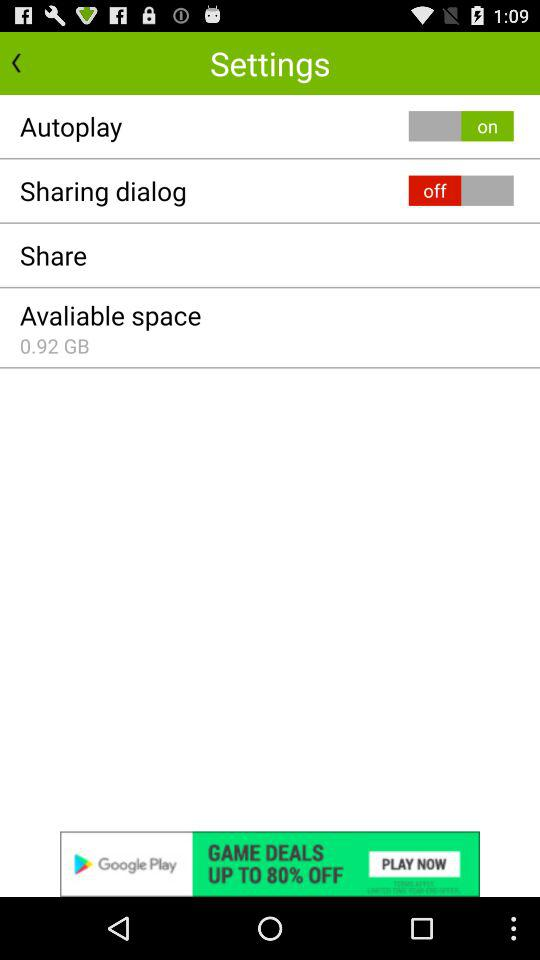How much space is available?
Answer the question using a single word or phrase. 0.92 GB 